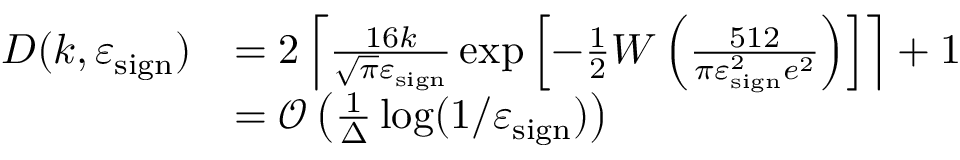Convert formula to latex. <formula><loc_0><loc_0><loc_500><loc_500>\begin{array} { r l } { D ( k , \varepsilon _ { s i g n } ) } & { = 2 \left \lceil \frac { 1 6 k } { \sqrt { \pi } \varepsilon _ { s i g n } } \exp \left [ - \frac { 1 } { 2 } W \left ( \frac { 5 1 2 } { \pi \varepsilon _ { s i g n } ^ { 2 } e ^ { 2 } } \right ) \right ] \right \rceil + 1 } \\ & { = \mathcal { O } \left ( \frac { 1 } { \Delta } \log ( 1 / \varepsilon _ { s i g n } ) \right ) } \end{array}</formula> 